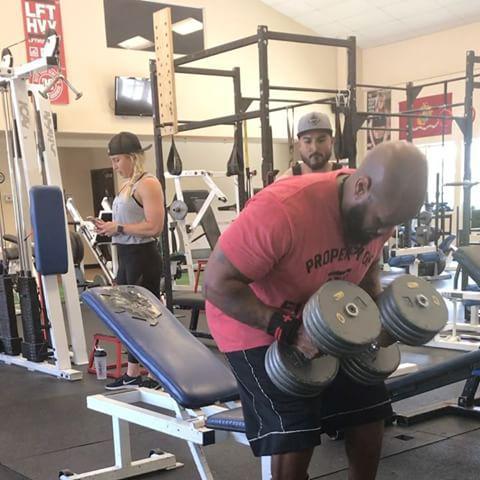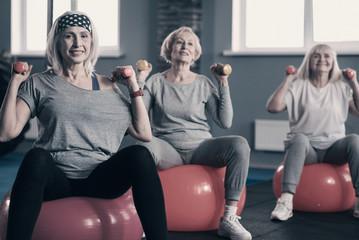The first image is the image on the left, the second image is the image on the right. Considering the images on both sides, is "An image shows three pale-haired women sitting on pink exercise balls." valid? Answer yes or no. Yes. The first image is the image on the left, the second image is the image on the right. Considering the images on both sides, is "Three women are sitting on exercise balls in one of the images." valid? Answer yes or no. Yes. 